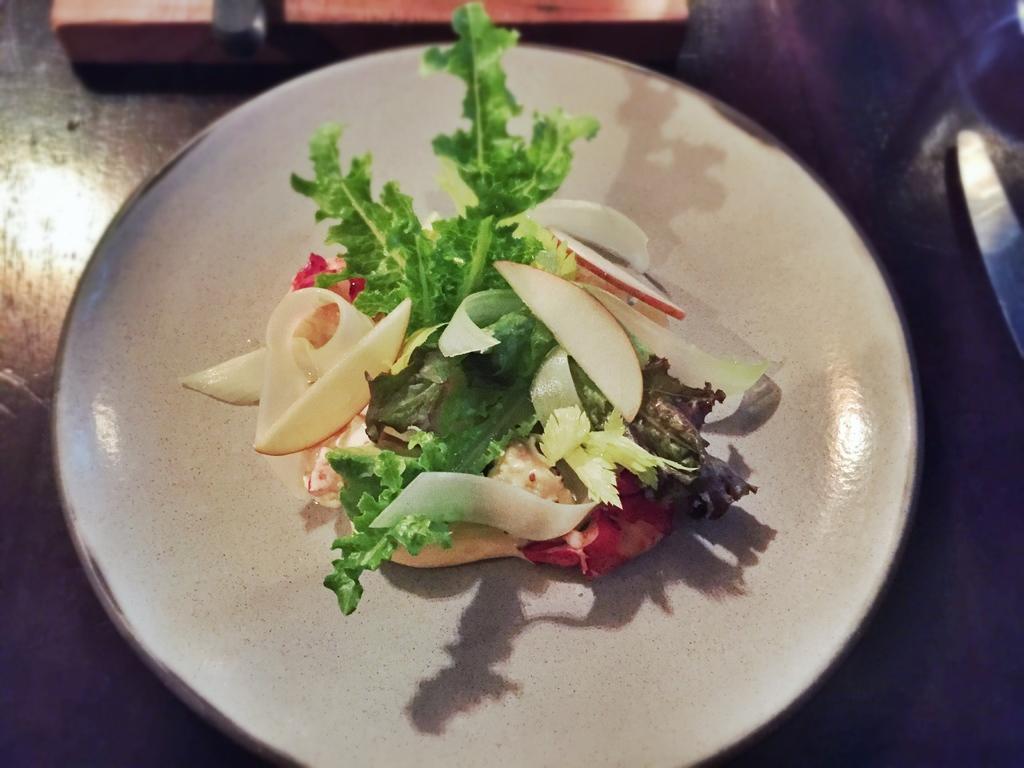In one or two sentences, can you explain what this image depicts? This picture shows salad in the plate. We see leaves and fruits. 